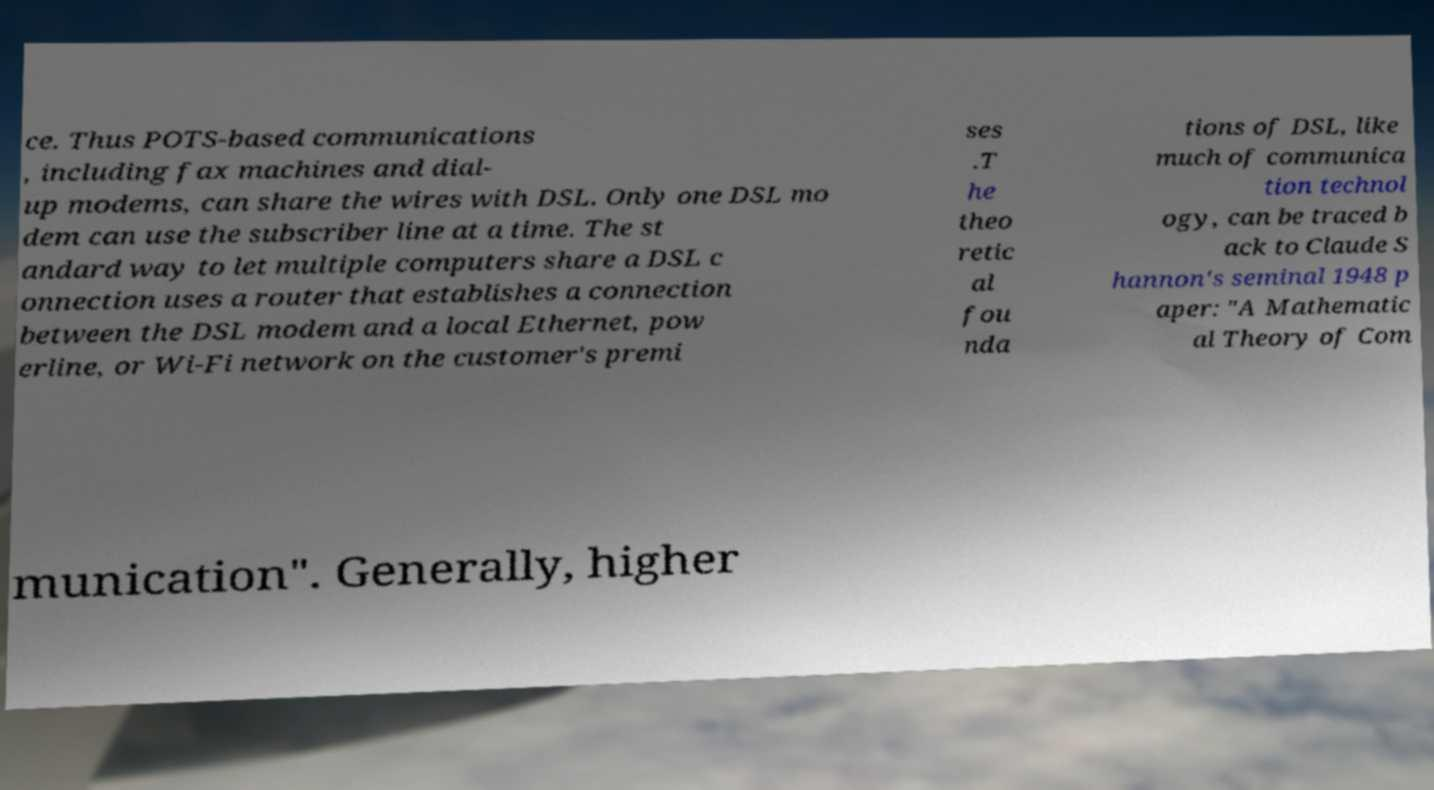For documentation purposes, I need the text within this image transcribed. Could you provide that? ce. Thus POTS-based communications , including fax machines and dial- up modems, can share the wires with DSL. Only one DSL mo dem can use the subscriber line at a time. The st andard way to let multiple computers share a DSL c onnection uses a router that establishes a connection between the DSL modem and a local Ethernet, pow erline, or Wi-Fi network on the customer's premi ses .T he theo retic al fou nda tions of DSL, like much of communica tion technol ogy, can be traced b ack to Claude S hannon's seminal 1948 p aper: "A Mathematic al Theory of Com munication". Generally, higher 